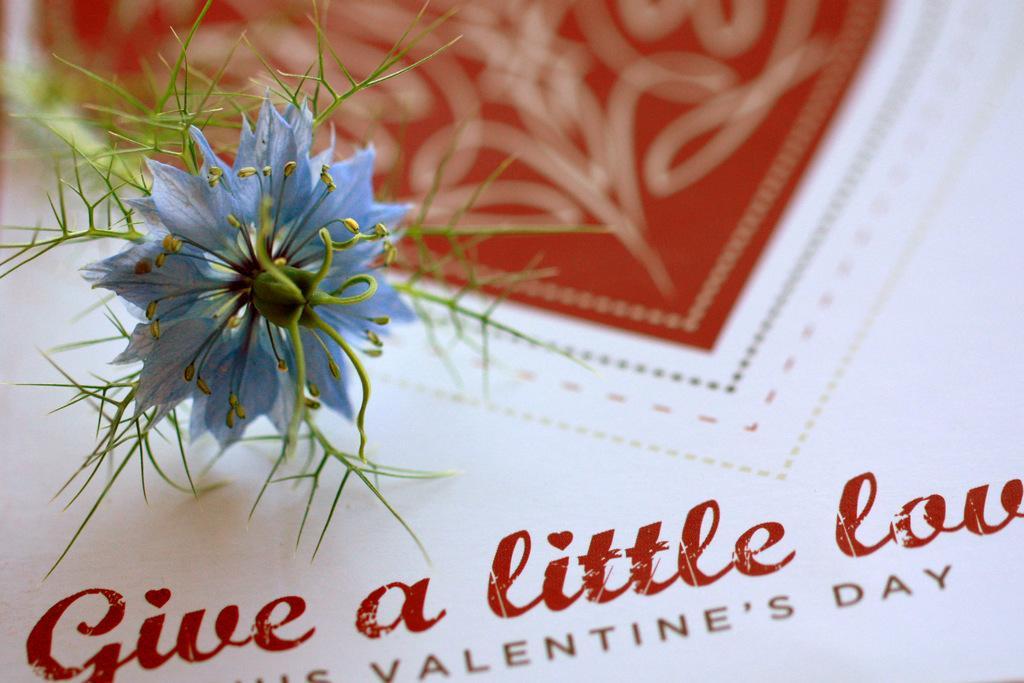Can you describe this image briefly? In this image we can see a flower on the card. 